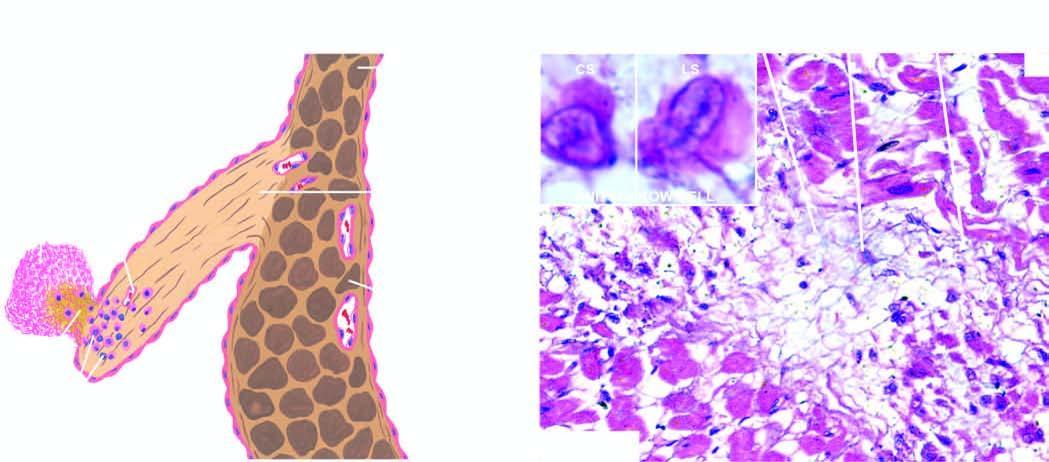what shows healed aschoff nodules in the interstitium having collagen, sparse cellula rity, a multinucleate giant cell and anitschkow cells?
Answer the question using a single word or phrase. Section of the myocardium cells 